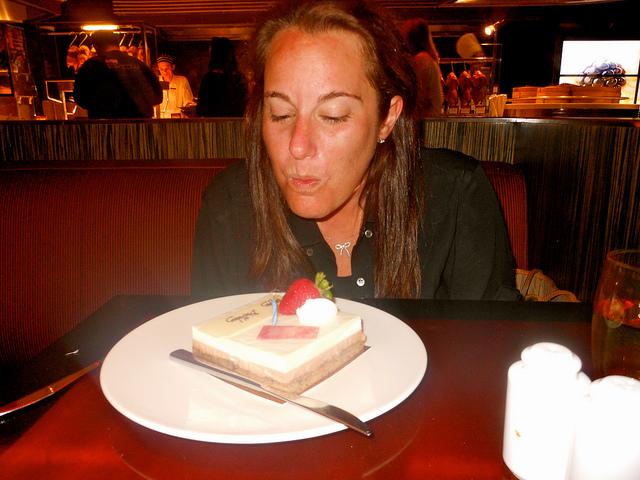Where is the bow?
Be succinct. On necklace. Where was this pic taken?
Be succinct. Restaurant. What type of utensil is shown?
Concise answer only. Knife. 